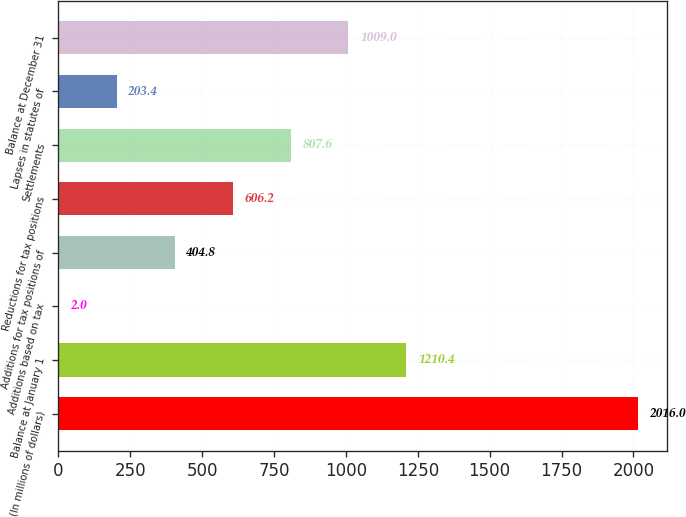Convert chart. <chart><loc_0><loc_0><loc_500><loc_500><bar_chart><fcel>(In millions of dollars)<fcel>Balance at January 1<fcel>Additions based on tax<fcel>Additions for tax positions of<fcel>Reductions for tax positions<fcel>Settlements<fcel>Lapses in statutes of<fcel>Balance at December 31<nl><fcel>2016<fcel>1210.4<fcel>2<fcel>404.8<fcel>606.2<fcel>807.6<fcel>203.4<fcel>1009<nl></chart> 